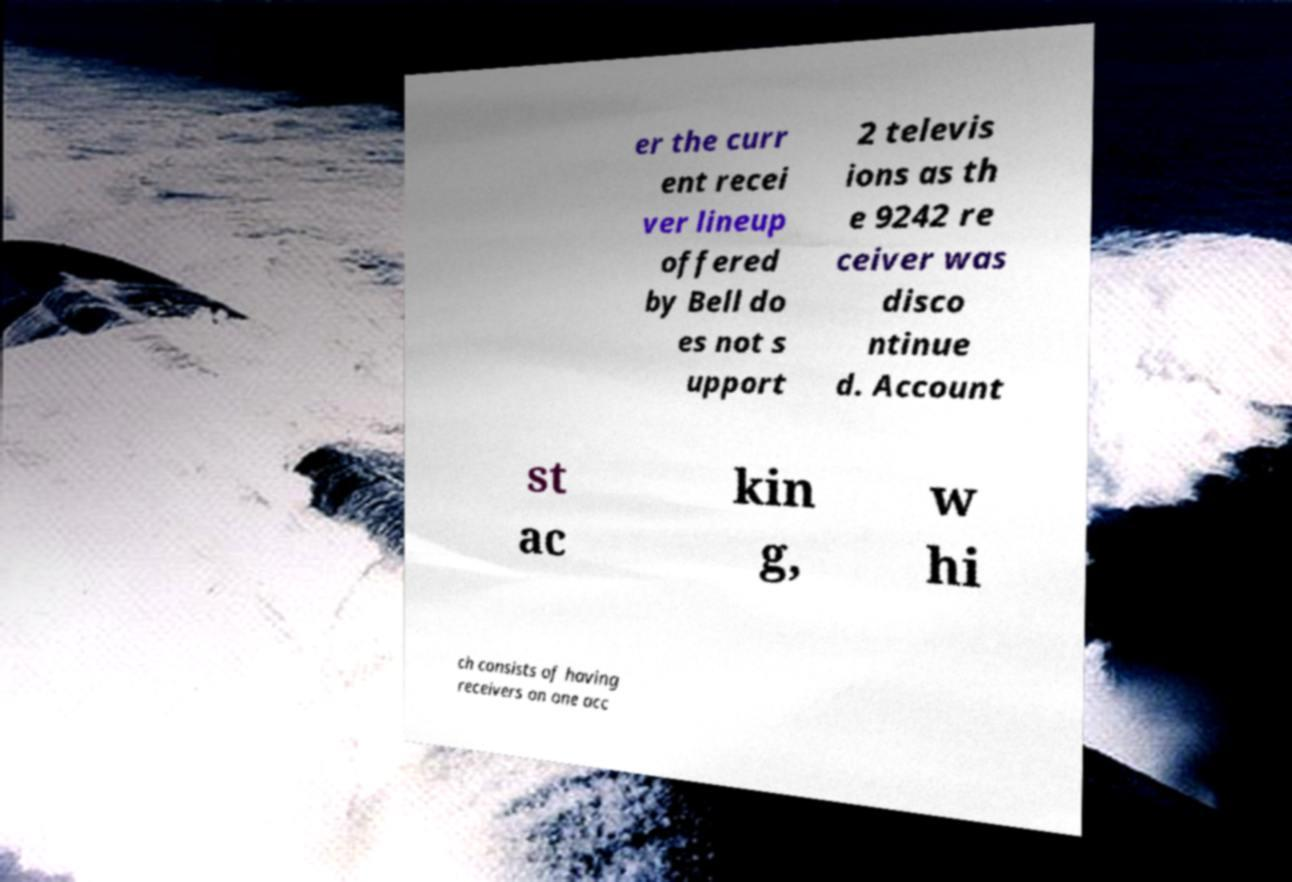Can you read and provide the text displayed in the image?This photo seems to have some interesting text. Can you extract and type it out for me? er the curr ent recei ver lineup offered by Bell do es not s upport 2 televis ions as th e 9242 re ceiver was disco ntinue d. Account st ac kin g, w hi ch consists of having receivers on one acc 